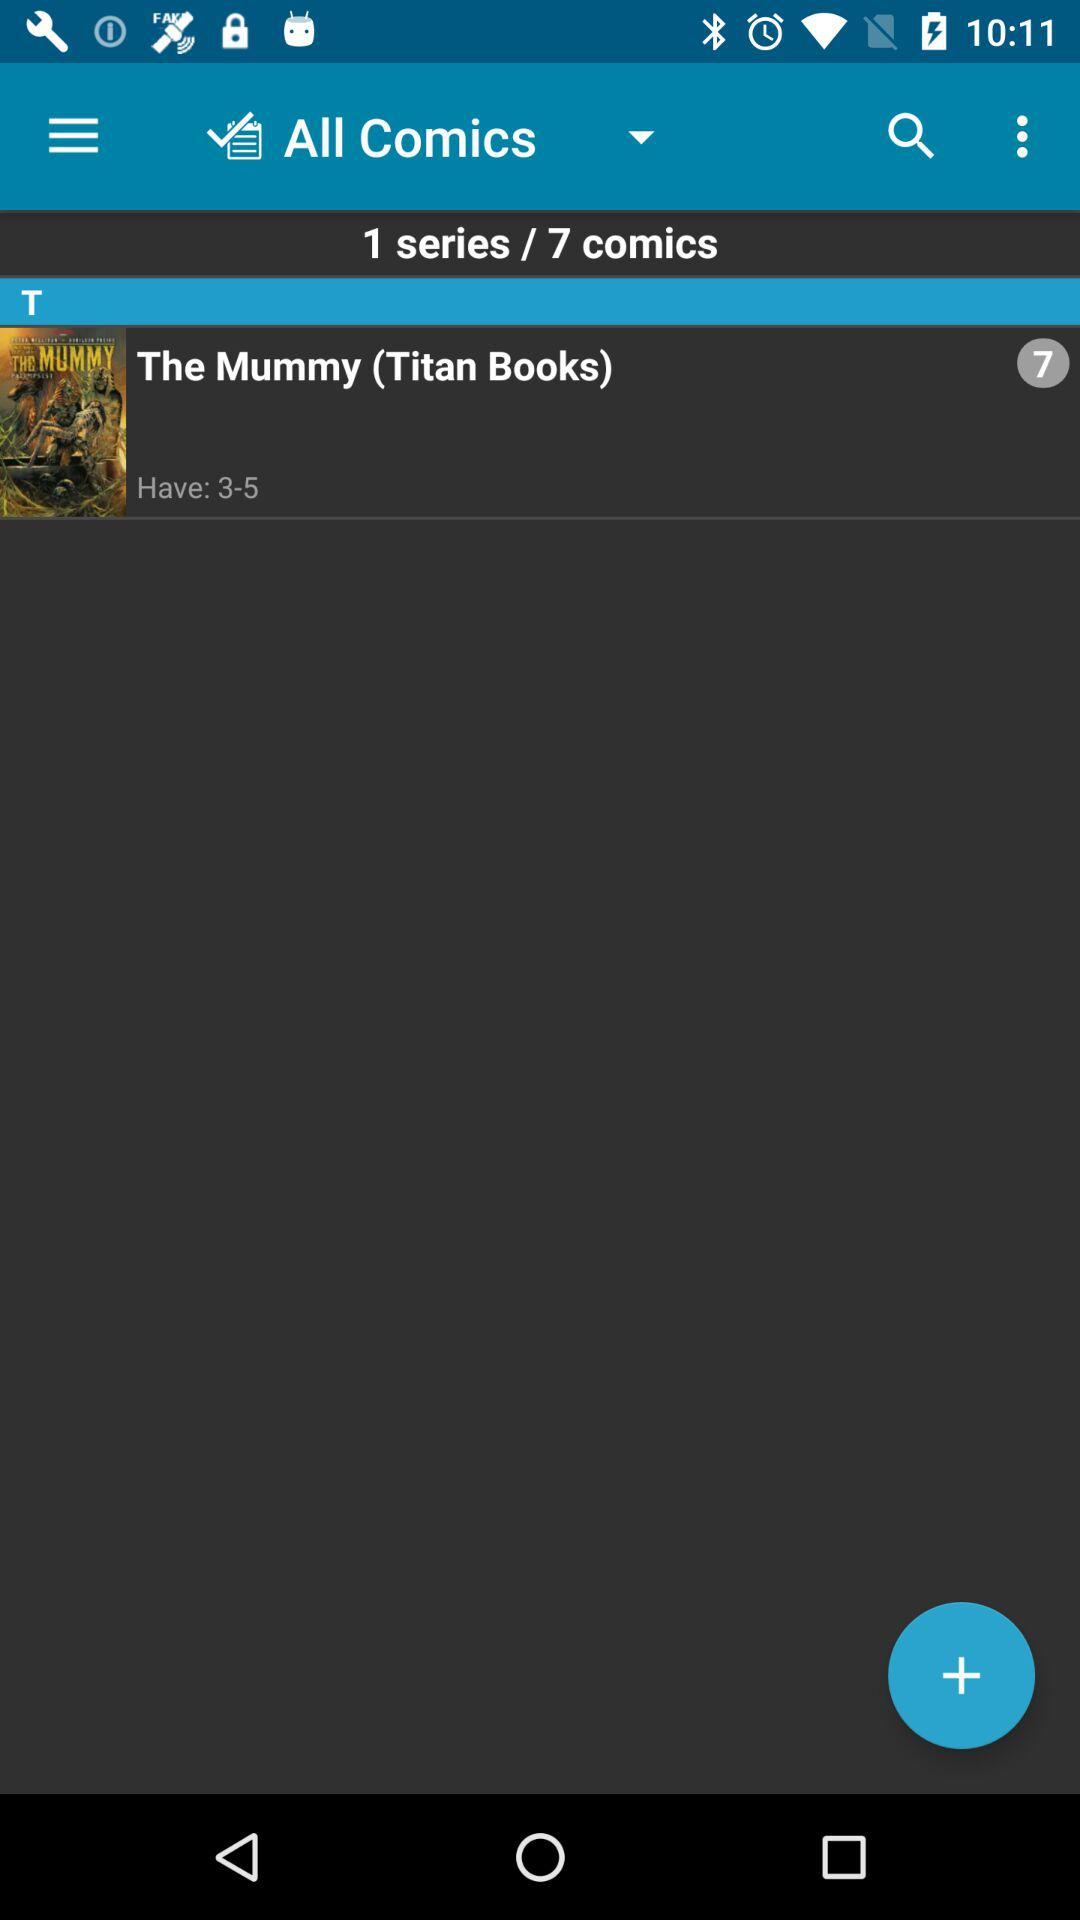How many comics are available in total?
Answer the question using a single word or phrase. 7 